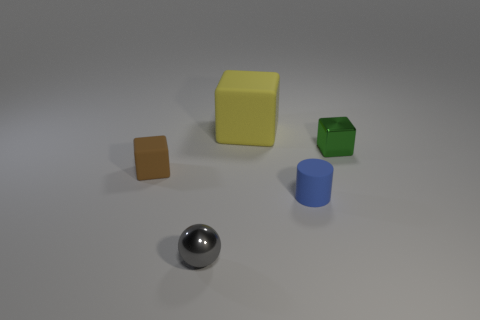What do you think is the material composition of these objects? Based on their visual characteristics, the objects appear to be made of different materials. The small orange and pale yellow blocks look like they could be made of a matte plastic, while the green cube could be a similar plastic material with a hollow section. The cylindrical blue object also seems to be made of plastic but with a glossy finish. The spherical object in the foreground has a metallic look, possibly chrome or stainless steel, due to its highly reflective surface. 
Is there anything about the lighting or shadows that stands out to you? The lighting in the image suggests a single overhead light source, as evidenced by the soft shadows cast directly underneath and slightly to the side of each object. The shadows are subtle yet provide a realistic sense of depth and position for each item. The reflective sphere captures light highlights and the environment, which indicates the meticulous placement and strength of the light source. 